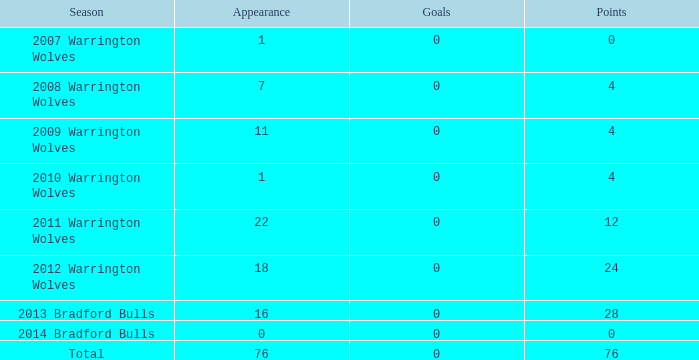What is the least appearance when goals exceed 0? None. 